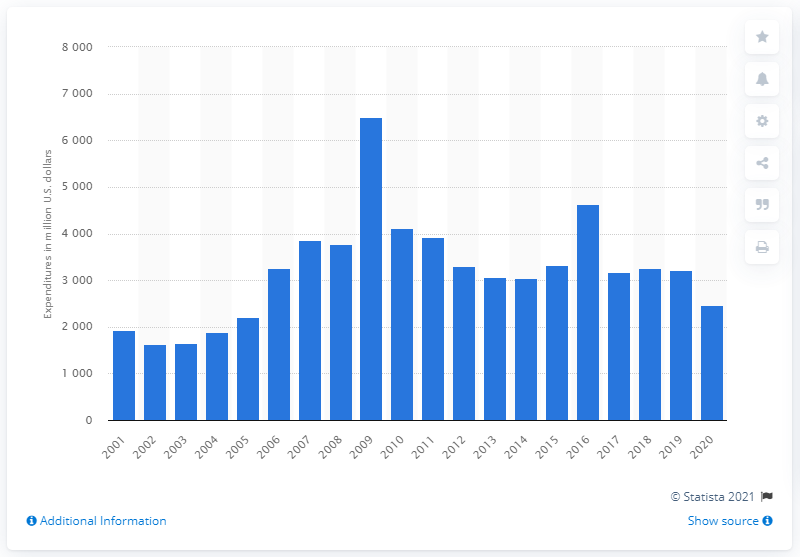Highlight a few significant elements in this photo. The highest level of research and development expenditure was in 2016. The research and development costs of Boeing in 2020 were 2,476. 